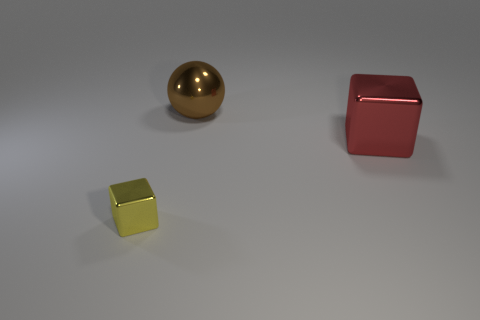There is a cube that is the same size as the shiny sphere; what is it made of?
Make the answer very short. Metal. There is a yellow metallic cube; is it the same size as the metallic thing that is behind the red shiny cube?
Offer a terse response. No. What number of metal things are red things or large spheres?
Your answer should be very brief. 2. How many other small yellow shiny things have the same shape as the small shiny thing?
Keep it short and to the point. 0. Does the block to the right of the small block have the same size as the object that is to the left of the big brown metallic thing?
Your answer should be compact. No. What shape is the large metallic object on the right side of the brown ball?
Your answer should be very brief. Cube. Is the size of the cube that is on the left side of the red object the same as the red thing?
Offer a very short reply. No. There is a big red metallic thing; how many tiny yellow things are on the left side of it?
Give a very brief answer. 1. Is the number of small shiny objects that are behind the big red metallic thing less than the number of small yellow metallic blocks in front of the large brown metal object?
Keep it short and to the point. Yes. How many yellow shiny blocks are there?
Make the answer very short. 1. 